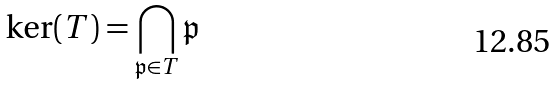<formula> <loc_0><loc_0><loc_500><loc_500>\ker ( T ) = \bigcap _ { \mathfrak { p } \in T } \mathfrak { p }</formula> 